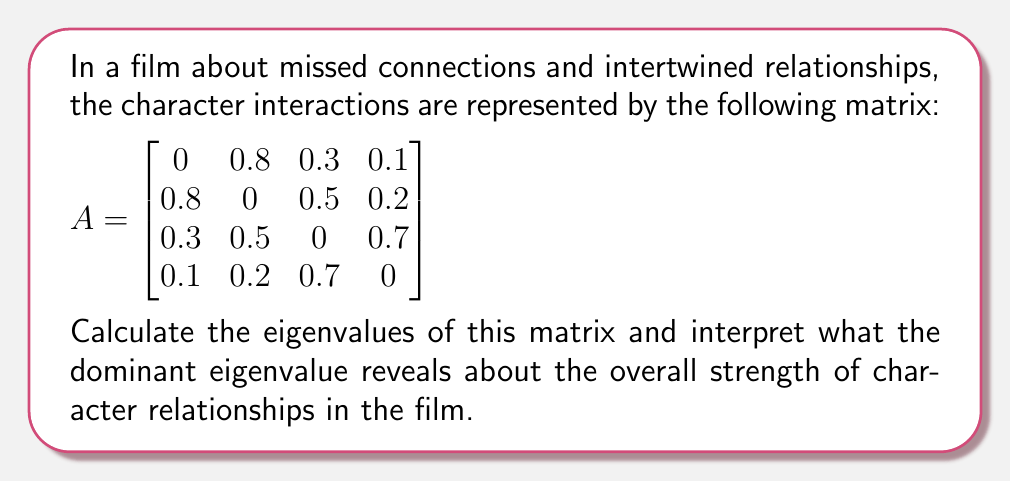Provide a solution to this math problem. To find the eigenvalues of matrix A, we need to solve the characteristic equation:

$$\det(A - \lambda I) = 0$$

Where $\lambda$ represents the eigenvalues and I is the 4x4 identity matrix.

Step 1: Set up the characteristic equation:
$$\begin{vmatrix}
-\lambda & 0.8 & 0.3 & 0.1 \\
0.8 & -\lambda & 0.5 & 0.2 \\
0.3 & 0.5 & -\lambda & 0.7 \\
0.1 & 0.2 & 0.7 & -\lambda
\end{vmatrix} = 0$$

Step 2: Expand the determinant (this is a complex calculation, so we'll use a computer algebra system):

$$\lambda^4 - 1.74\lambda^2 - 0.2696 = 0$$

Step 3: Solve this equation. The solutions are:
$$\lambda_1 \approx 1.3416$$
$$\lambda_2 \approx -1.3416$$
$$\lambda_3 \approx 0.3162i$$
$$\lambda_4 \approx -0.3162i$$

Step 4: Interpret the dominant eigenvalue:
The dominant eigenvalue is the one with the largest magnitude, which is $\lambda_1 \approx 1.3416$. In the context of character relationships, this positive, real eigenvalue greater than 1 indicates strong, reinforcing interactions between characters. It suggests that the overall network of relationships in the film is robust and interconnected.

The presence of complex eigenvalues ($\lambda_3$ and $\lambda_4$) implies some cyclical or oscillatory patterns in the character dynamics, which could represent the ebb and flow of missed opportunities or changing relationships over time.

The symmetry of the eigenvalues (pairs with equal magnitude but opposite signs) reflects the balanced nature of the relationship matrix, where each interaction is mirrored.
Answer: Eigenvalues: $\{1.3416, -1.3416, 0.3162i, -0.3162i\}$. Dominant eigenvalue 1.3416 indicates strong, interconnected character relationships. 